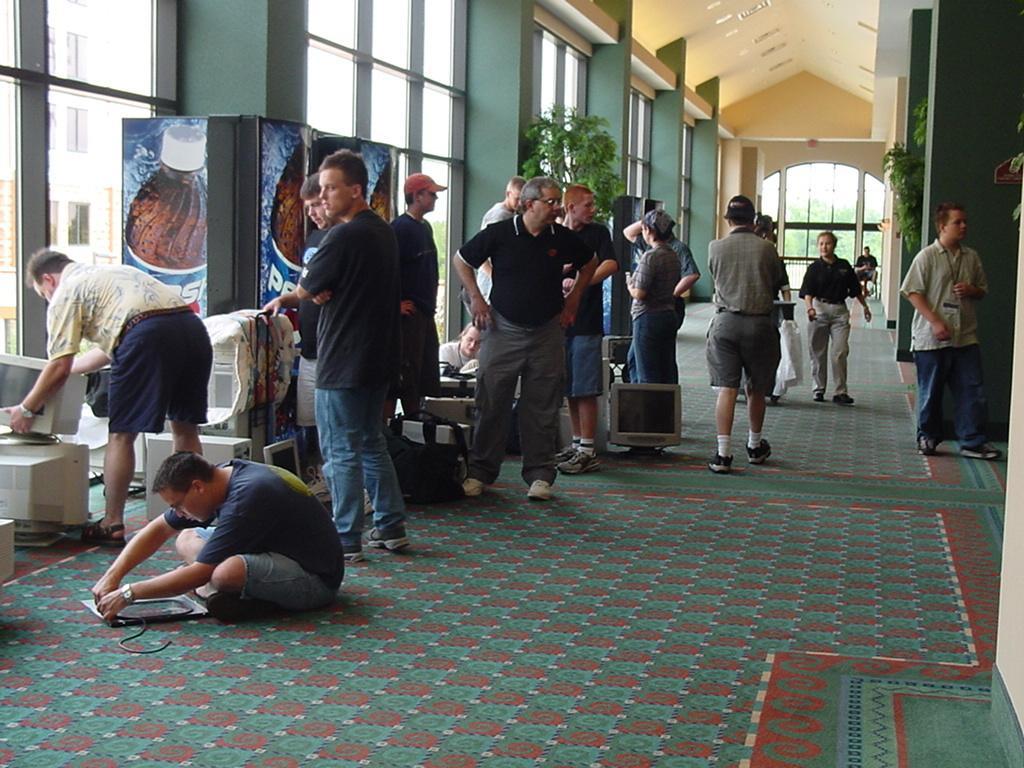In one or two sentences, can you explain what this image depicts? In this picture I can see many people who are standing near to the computers. On the left there is a man who is sitting on the carpet and doing some work, beside him there is a man who is holding a computer screen, beside him I can see the banner which is placed near to the glass partition and pillar. On the right there is a man who is standing near to the pillar and plants. In the left background I can see the buildings. in the top right corner I can see some lights. Through the door I can see the plants. 